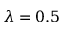<formula> <loc_0><loc_0><loc_500><loc_500>\lambda = 0 . 5</formula> 